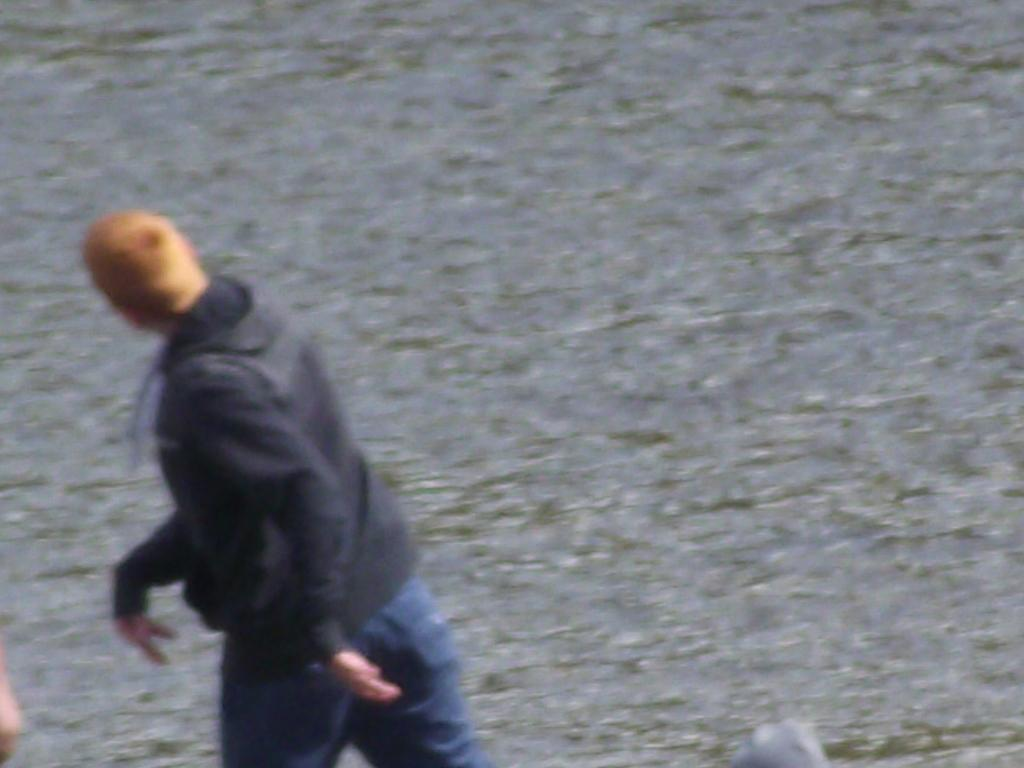Who or what is present in the image? There is a person in the image. What type of clothing is the person wearing? The person is wearing jeans. What can be seen in the background of the image? There is water visible in the background of the image. What vacation destination does the person suggest in the image? The image does not depict a conversation or suggestion about a vacation destination. 